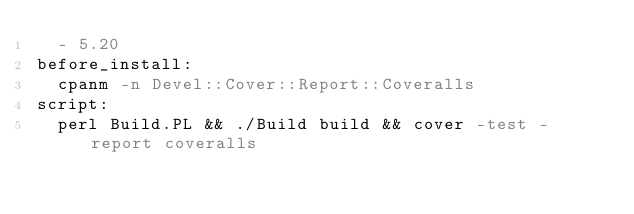Convert code to text. <code><loc_0><loc_0><loc_500><loc_500><_YAML_>  - 5.20
before_install:
  cpanm -n Devel::Cover::Report::Coveralls
script:
  perl Build.PL && ./Build build && cover -test -report coveralls
</code> 